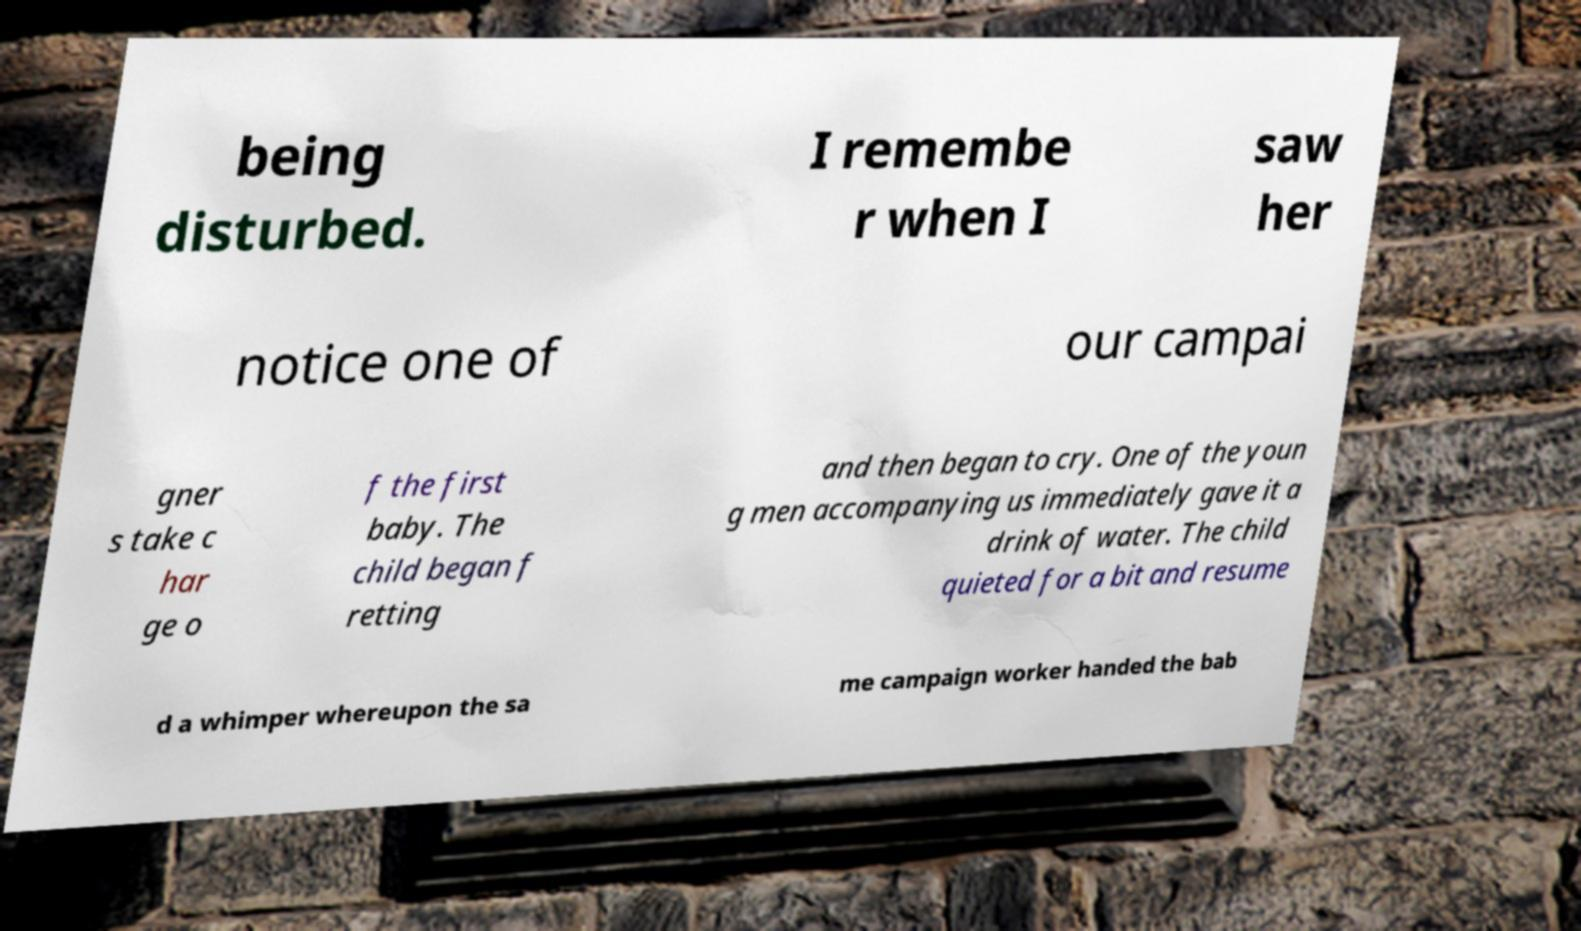Could you extract and type out the text from this image? being disturbed. I remembe r when I saw her notice one of our campai gner s take c har ge o f the first baby. The child began f retting and then began to cry. One of the youn g men accompanying us immediately gave it a drink of water. The child quieted for a bit and resume d a whimper whereupon the sa me campaign worker handed the bab 